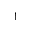<formula> <loc_0><loc_0><loc_500><loc_500>^ { \dagger }</formula> 